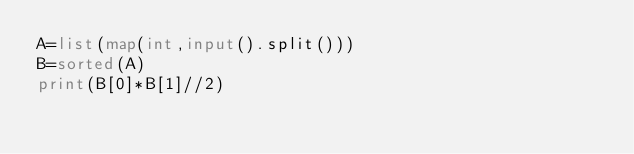Convert code to text. <code><loc_0><loc_0><loc_500><loc_500><_Python_>A=list(map(int,input().split()))
B=sorted(A)
print(B[0]*B[1]//2)</code> 